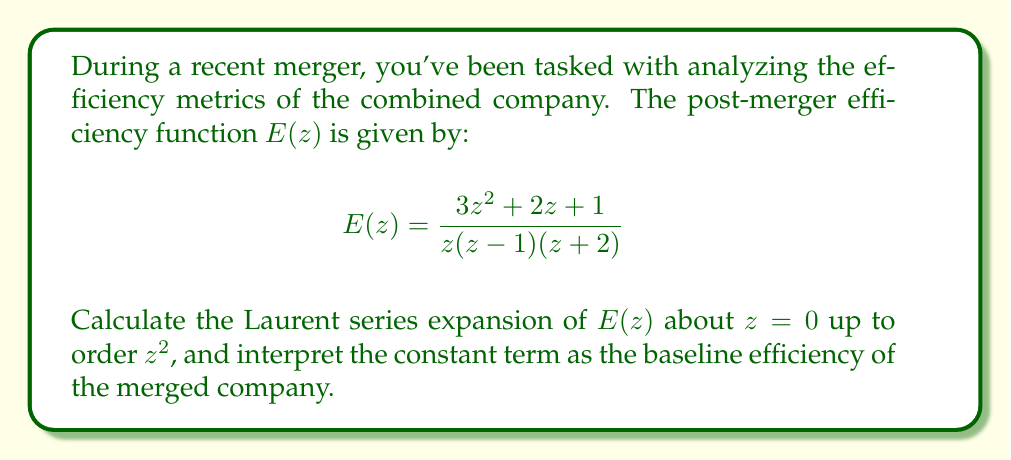Provide a solution to this math problem. To find the Laurent series expansion of $E(z)$ about $z=0$, we need to follow these steps:

1) First, let's perform a partial fraction decomposition of $E(z)$:

   $$E(z) = \frac{3z^2 + 2z + 1}{z(z-1)(z+2)} = \frac{A}{z} + \frac{B}{z-1} + \frac{C}{z+2}$$

2) Solving for A, B, and C:
   
   $A = \lim_{z \to 0} zE(z) = \frac{1}{2}$
   $B = \lim_{z \to 1} (z-1)E(z) = -\frac{5}{3}$
   $C = \lim_{z \to -2} (z+2)E(z) = \frac{7}{6}$

3) Now we have:

   $$E(z) = \frac{1/2}{z} - \frac{5/3}{z-1} + \frac{7/6}{z+2}$$

4) Expand each term as a Laurent series about $z=0$:

   $\frac{1/2}{z} = \frac{1}{2z}$
   
   $-\frac{5/3}{z-1} = -\frac{5}{3}(-\frac{1}{1-z}) = -\frac{5}{3}(1 + z + z^2 + ...)$
   
   $\frac{7/6}{z+2} = \frac{7}{6}(\frac{1}{2} - \frac{z}{4} + \frac{z^2}{8} - ...)$

5) Combining these expansions and collecting terms up to $z^2$:

   $$E(z) = \frac{1}{2z} + (-\frac{5}{3} + \frac{7}{12}) + (-\frac{5}{3} - \frac{7}{24})z + (-\frac{5}{3} + \frac{7}{48})z^2 + ...$$

6) Simplifying:

   $$E(z) = \frac{1}{2z} - \frac{13}{12} - \frac{47}{24}z - \frac{73}{48}z^2 + O(z^3)$$

The constant term $-\frac{13}{12}$ represents the baseline efficiency of the merged company.
Answer: $$E(z) = \frac{1}{2z} - \frac{13}{12} - \frac{47}{24}z - \frac{73}{48}z^2 + O(z^3)$$

The baseline efficiency of the merged company is $-\frac{13}{12}$. 